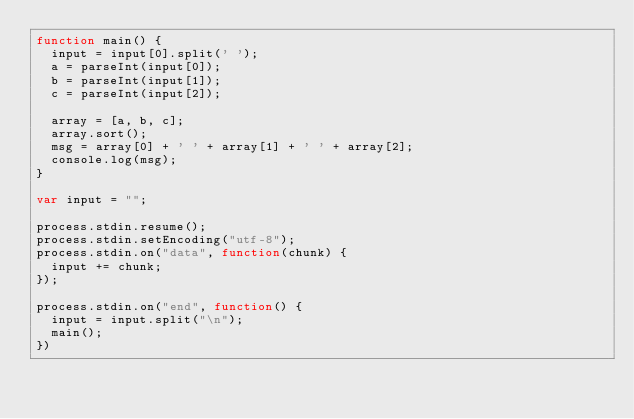Convert code to text. <code><loc_0><loc_0><loc_500><loc_500><_JavaScript_>function main() {
	input = input[0].split(' ');
	a = parseInt(input[0]);
	b = parseInt(input[1]);
	c = parseInt(input[2]);

	array = [a, b, c];
	array.sort();
	msg = array[0] + ' ' + array[1] + ' ' + array[2];
	console.log(msg);
}

var input = "";

process.stdin.resume();
process.stdin.setEncoding("utf-8");
process.stdin.on("data", function(chunk) {
	input += chunk;
});

process.stdin.on("end", function() {
	input = input.split("\n");
	main();
})</code> 